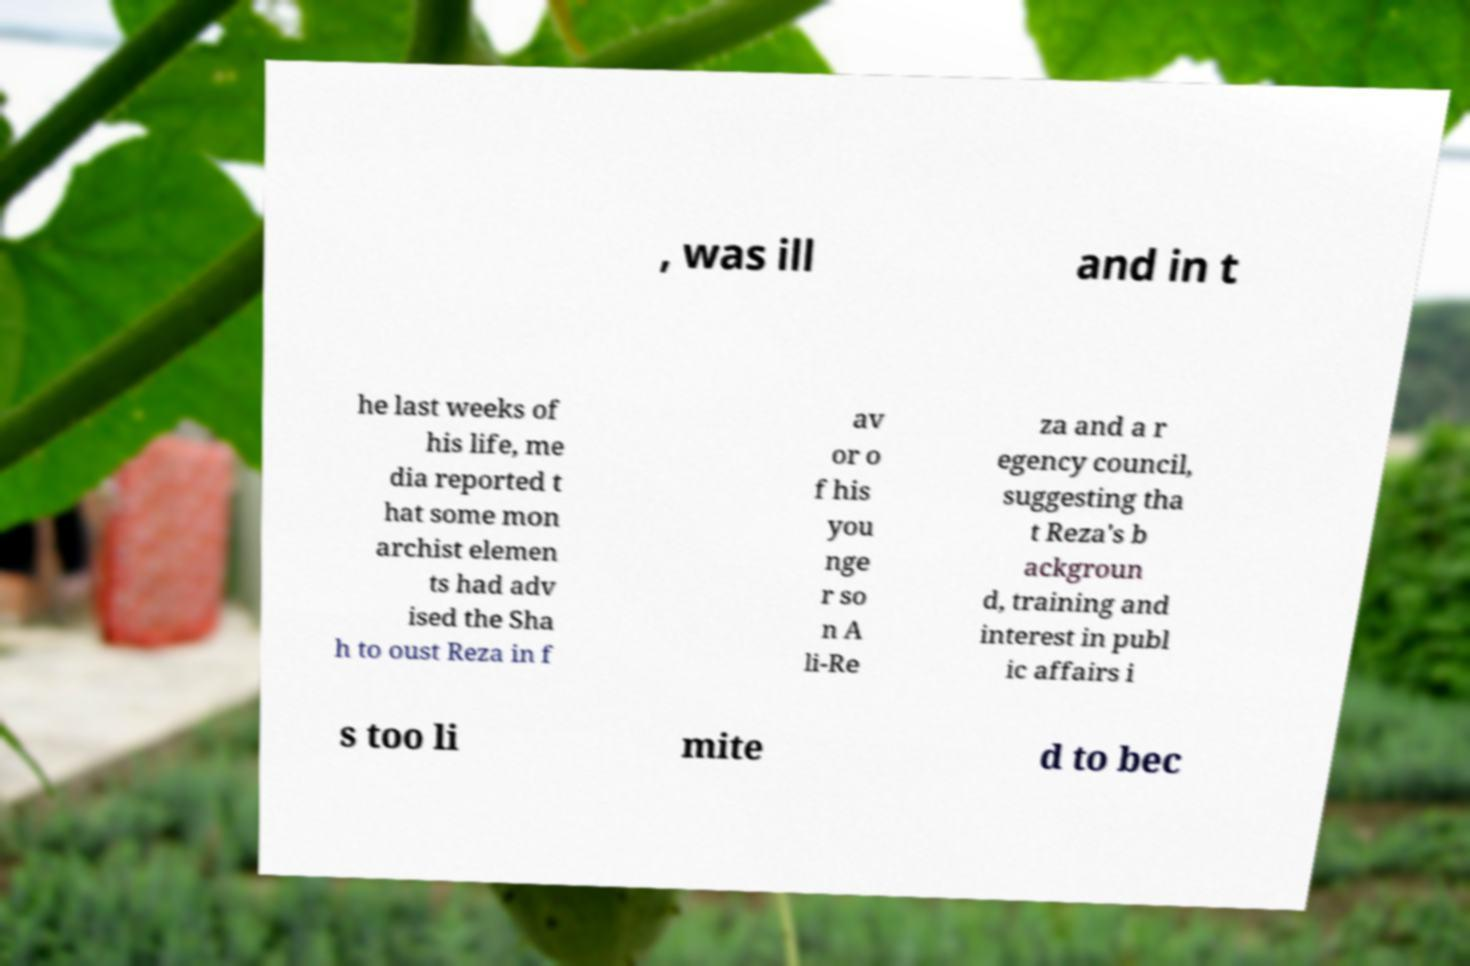Could you assist in decoding the text presented in this image and type it out clearly? , was ill and in t he last weeks of his life, me dia reported t hat some mon archist elemen ts had adv ised the Sha h to oust Reza in f av or o f his you nge r so n A li-Re za and a r egency council, suggesting tha t Reza's b ackgroun d, training and interest in publ ic affairs i s too li mite d to bec 